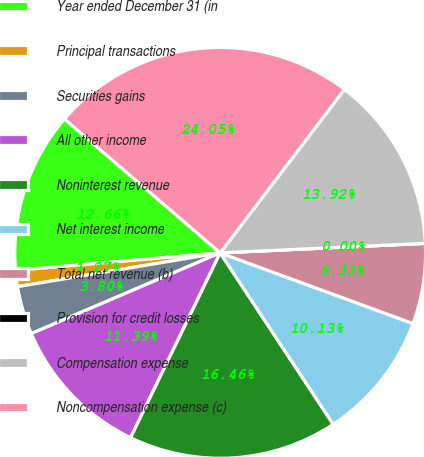<chart> <loc_0><loc_0><loc_500><loc_500><pie_chart><fcel>Year ended December 31 (in<fcel>Principal transactions<fcel>Securities gains<fcel>All other income<fcel>Noninterest revenue<fcel>Net interest income<fcel>Total net revenue (b)<fcel>Provision for credit losses<fcel>Compensation expense<fcel>Noncompensation expense (c)<nl><fcel>12.66%<fcel>1.27%<fcel>3.8%<fcel>11.39%<fcel>16.46%<fcel>10.13%<fcel>6.33%<fcel>0.0%<fcel>13.92%<fcel>24.05%<nl></chart> 